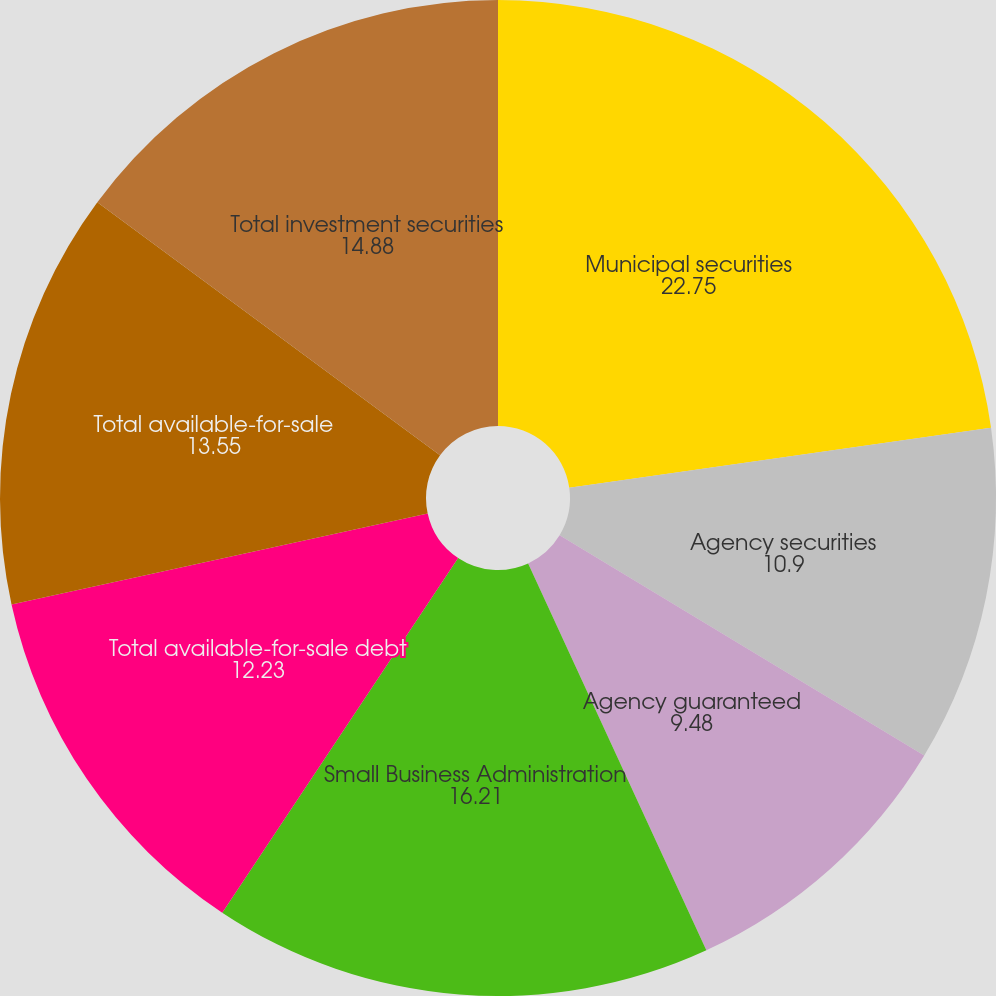Convert chart to OTSL. <chart><loc_0><loc_0><loc_500><loc_500><pie_chart><fcel>Municipal securities<fcel>Agency securities<fcel>Agency guaranteed<fcel>Small Business Administration<fcel>Total available-for-sale debt<fcel>Total available-for-sale<fcel>Total investment securities<nl><fcel>22.75%<fcel>10.9%<fcel>9.48%<fcel>16.21%<fcel>12.23%<fcel>13.55%<fcel>14.88%<nl></chart> 